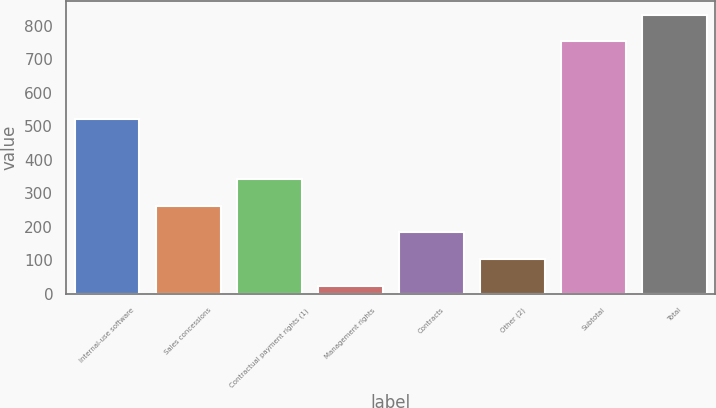<chart> <loc_0><loc_0><loc_500><loc_500><bar_chart><fcel>Internal-use software<fcel>Sales concessions<fcel>Contractual payment rights (1)<fcel>Management rights<fcel>Contracts<fcel>Other (2)<fcel>Subtotal<fcel>Total<nl><fcel>521<fcel>263.1<fcel>342.8<fcel>24<fcel>183.4<fcel>103.7<fcel>753<fcel>832.7<nl></chart> 